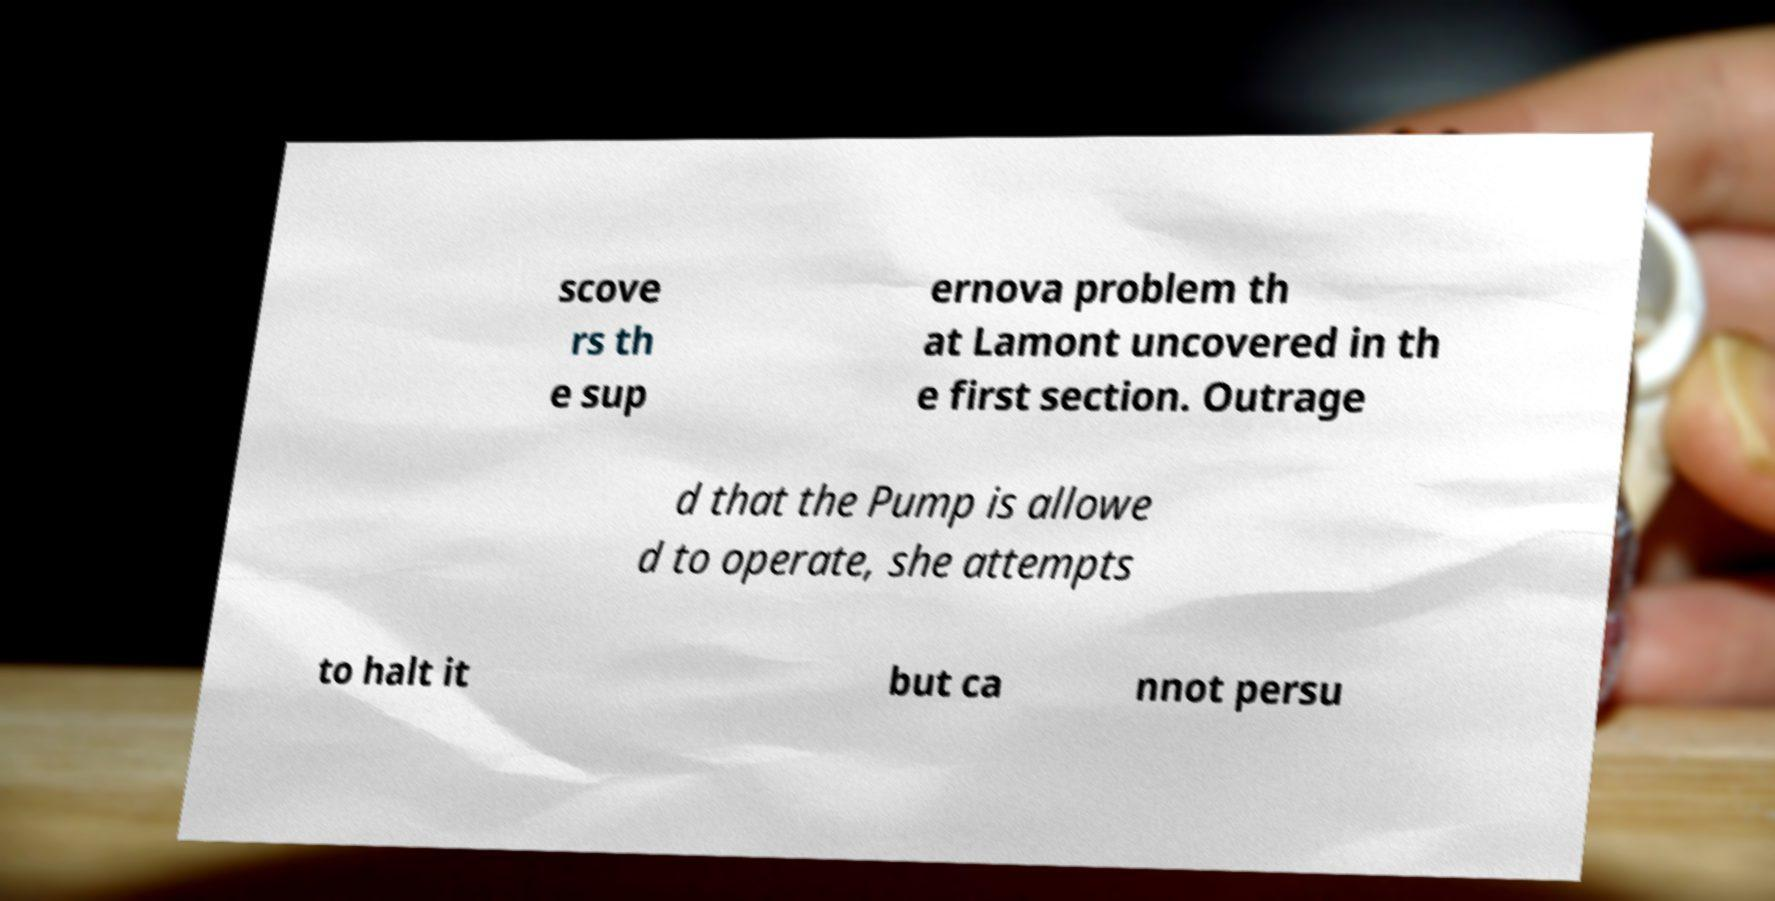Please identify and transcribe the text found in this image. scove rs th e sup ernova problem th at Lamont uncovered in th e first section. Outrage d that the Pump is allowe d to operate, she attempts to halt it but ca nnot persu 